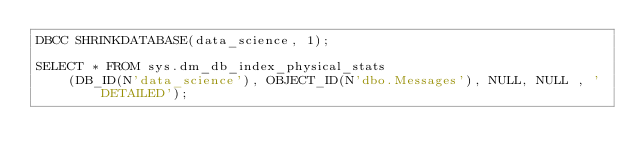<code> <loc_0><loc_0><loc_500><loc_500><_SQL_>DBCC SHRINKDATABASE(data_science, 1);

SELECT * FROM sys.dm_db_index_physical_stats  
    (DB_ID(N'data_science'), OBJECT_ID(N'dbo.Messages'), NULL, NULL , 'DETAILED');
</code> 